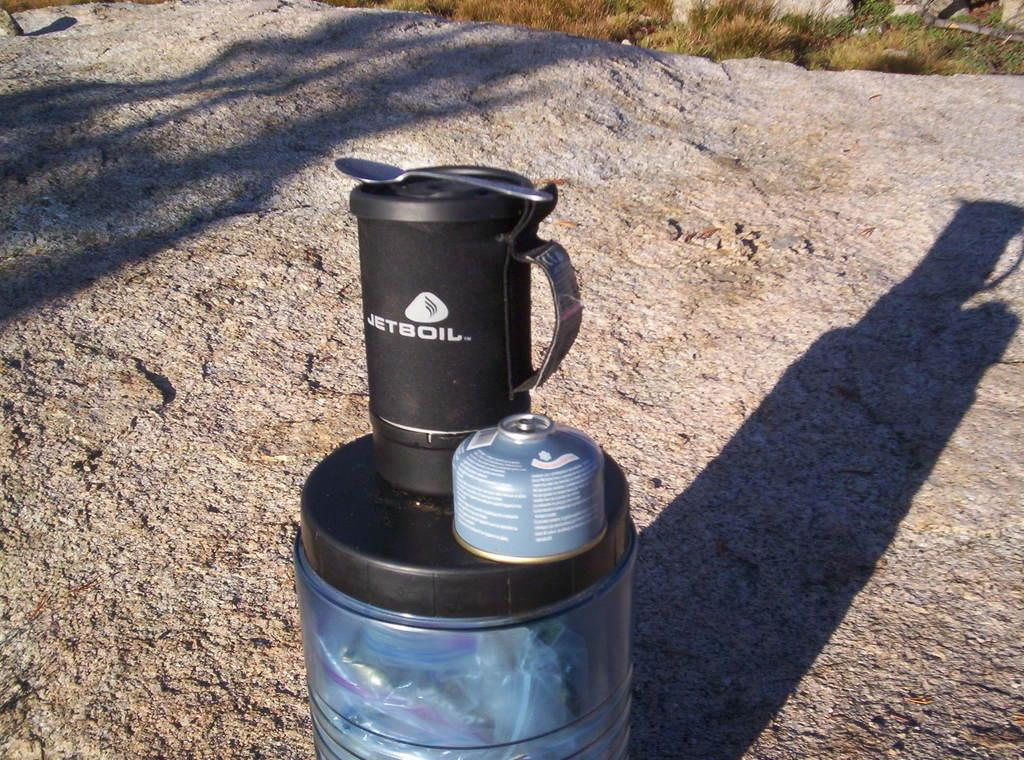Provide a one-sentence caption for the provided image. A container with JETBOIL sits atop another container. 